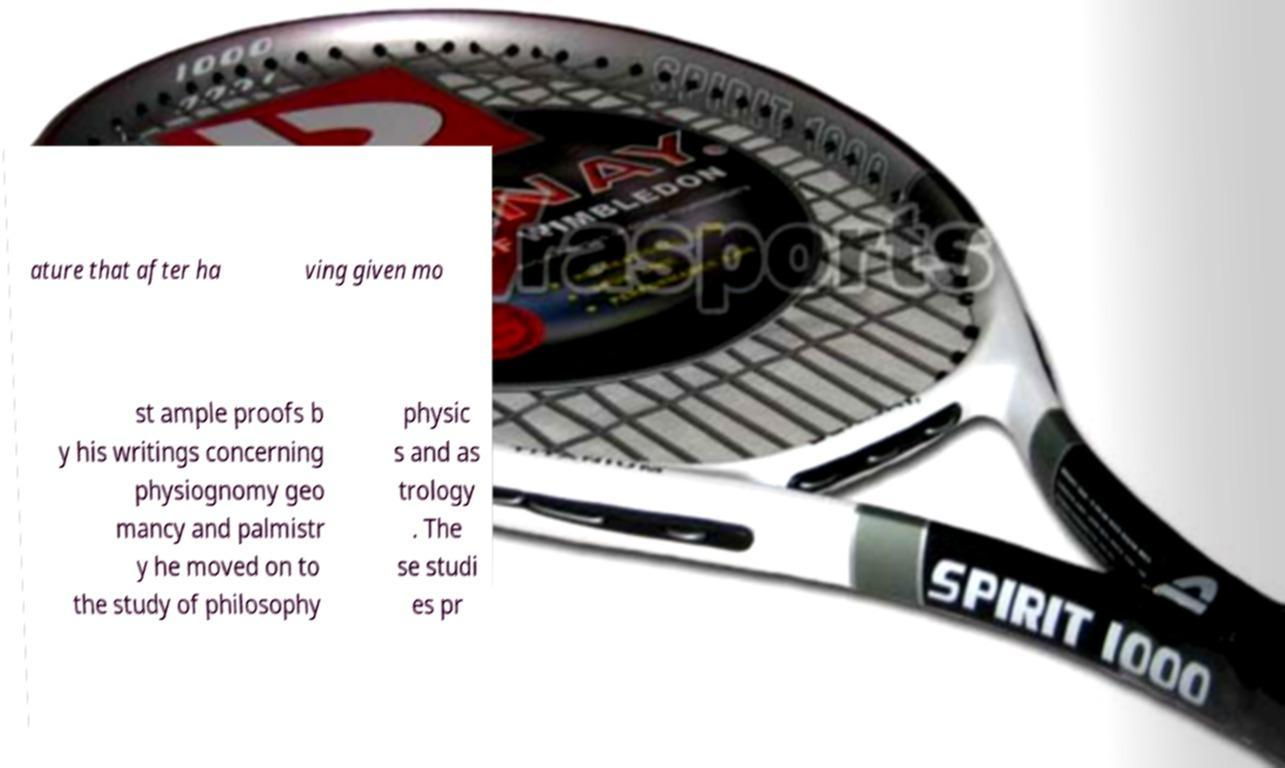Please read and relay the text visible in this image. What does it say? ature that after ha ving given mo st ample proofs b y his writings concerning physiognomy geo mancy and palmistr y he moved on to the study of philosophy physic s and as trology . The se studi es pr 